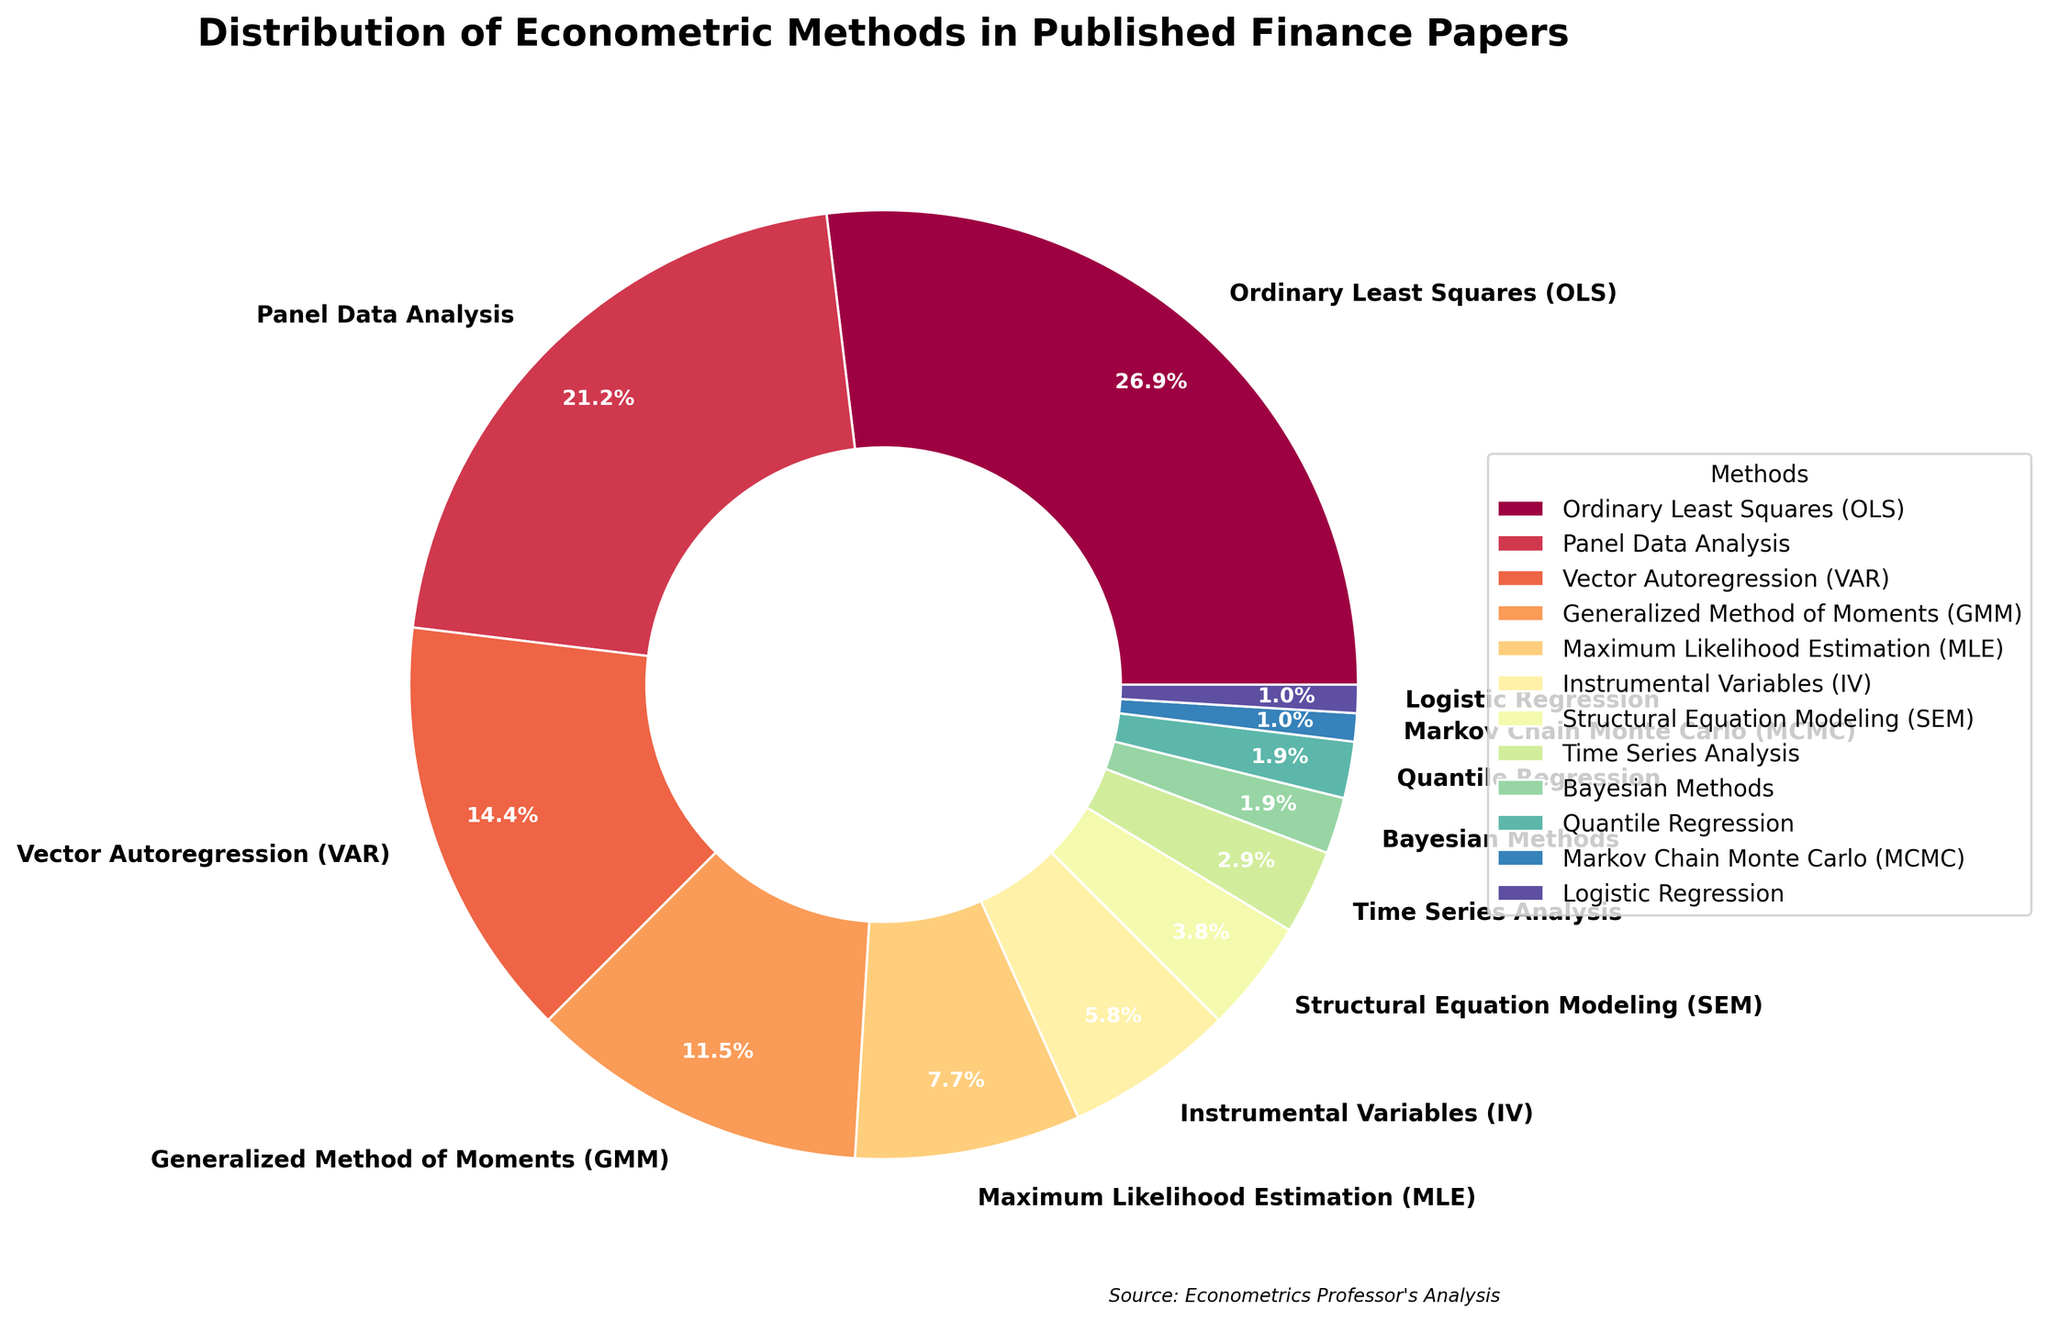Which econometric method is most frequently used in published finance papers? The pie chart shows different econometric methods along with their usage percentages. 'Ordinary Least Squares (OLS)' has the largest percentage wedge, which is 28%.
Answer: Ordinary Least Squares (OLS) What is the combined percentage of Panel Data Analysis and Vector Autoregression (VAR)? From the pie chart, Panel Data Analysis has 22% and Vector Autoregression (VAR) has 15%. Adding them together: 22% + 15% = 37%.
Answer: 37% Which econometric method occupies the smallest portion of the pie chart? By visual inspection, 'Logistic Regression' and 'Markov Chain Monte Carlo (MCMC)' both occupy the smallest portions at 1% each.
Answer: Logistic Regression and Markov Chain Monte Carlo (MCMC) Is the use of Generalized Method of Moments (GMM) more frequent than Maximum Likelihood Estimation (MLE)? The pie chart shows Generalized Method of Moments (GMM) at 12% and Maximum Likelihood Estimation (MLE) at 8%. Since 12% > 8%, GMM is more frequently used than MLE.
Answer: Yes How many econometric methods have a usage percentage below 5%? Examining the pie chart, the methods below 5% are Structural Equation Modeling (4%), Time Series Analysis (3%), Quantile Regression (2%), Bayesian Methods (2%), Logistic Regression (1%), and Markov Chain Monte Carlo (1%). There are 6 such methods.
Answer: 6 What is the difference in usage percentage between Instrumental Variables (IV) and Quantile Regression? The pie chart shows Instrumental Variables (IV) at 6% and Quantile Regression at 2%. The difference between them is 6% - 2% = 4%.
Answer: 4% Are Bayesian Methods used as frequently as Time Series Analysis? From the pie chart, Bayesian Methods and Time Series Analysis have percentages of 2% and 3%, respectively. Thus, Bayesian Methods are not used as frequently as Time Series Analysis.
Answer: No Which econometric method has a usage percentage closest to Structural Equation Modeling (SEM)? Structural Equation Modeling (SEM) has a usage percentage of 4%. Time Series Analysis has 3%, which is closest to 4% compared to other percentages.
Answer: Time Series Analysis What is the ratio of the combined usage of Maximum Likelihood Estimation (MLE) and Instrumental Variables (IV) to that of Ordinary Least Squares (OLS)? MLE has 8% and IV has 6%, summing to 14%. OLS has 28%. The ratio is 14% / 28% = 0.5.
Answer: 0.5 What is the median usage percentage among all the econometric methods? To find the median, we list all percentages in ascending order: 1%, 1%, 2%, 2%, 3%, 4%, 6%, 8%, 12%, 15%, 22%, 28%. There are 12 values; the median is the average of the 6th and 7th values: (4% + 6%) / 2 = 5%.
Answer: 5% 